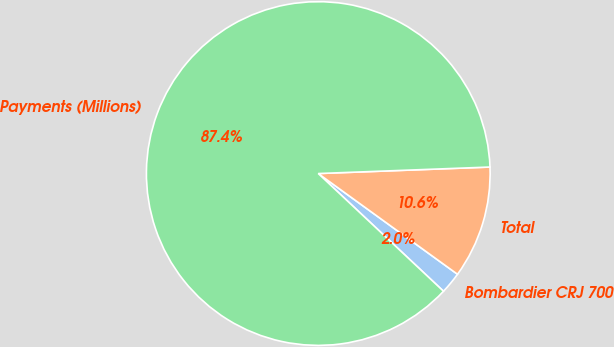Convert chart. <chart><loc_0><loc_0><loc_500><loc_500><pie_chart><fcel>Bombardier CRJ 700<fcel>Total<fcel>Payments (Millions)<nl><fcel>2.04%<fcel>10.57%<fcel>87.39%<nl></chart> 